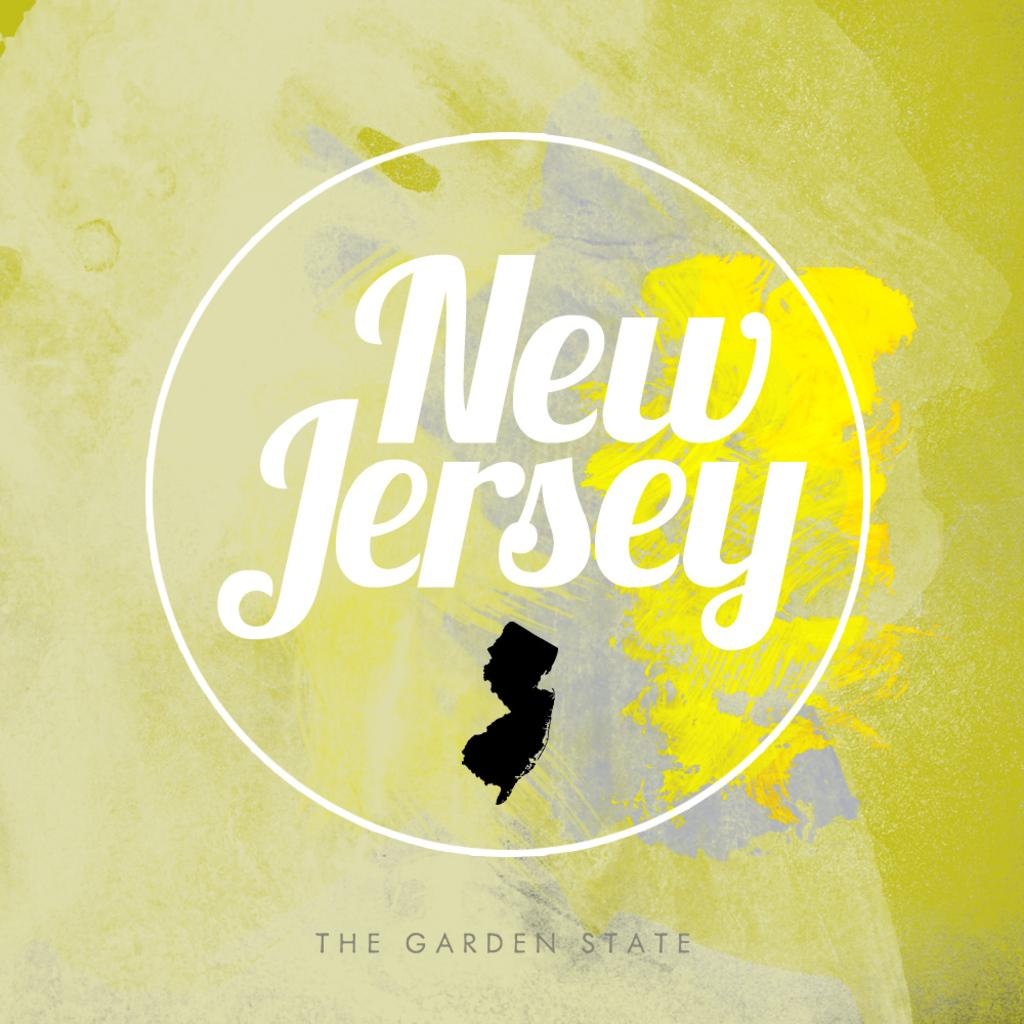<image>
Give a short and clear explanation of the subsequent image. A map of New Jersey and the Garden State. 